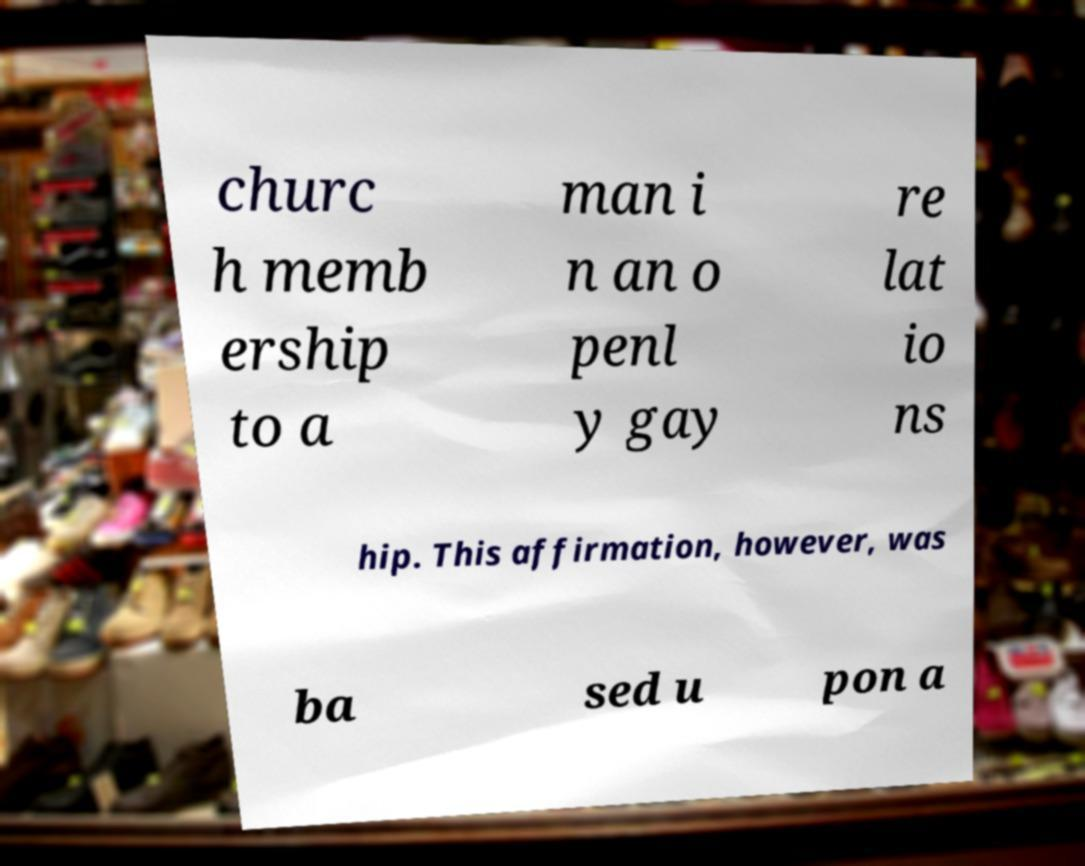I need the written content from this picture converted into text. Can you do that? churc h memb ership to a man i n an o penl y gay re lat io ns hip. This affirmation, however, was ba sed u pon a 